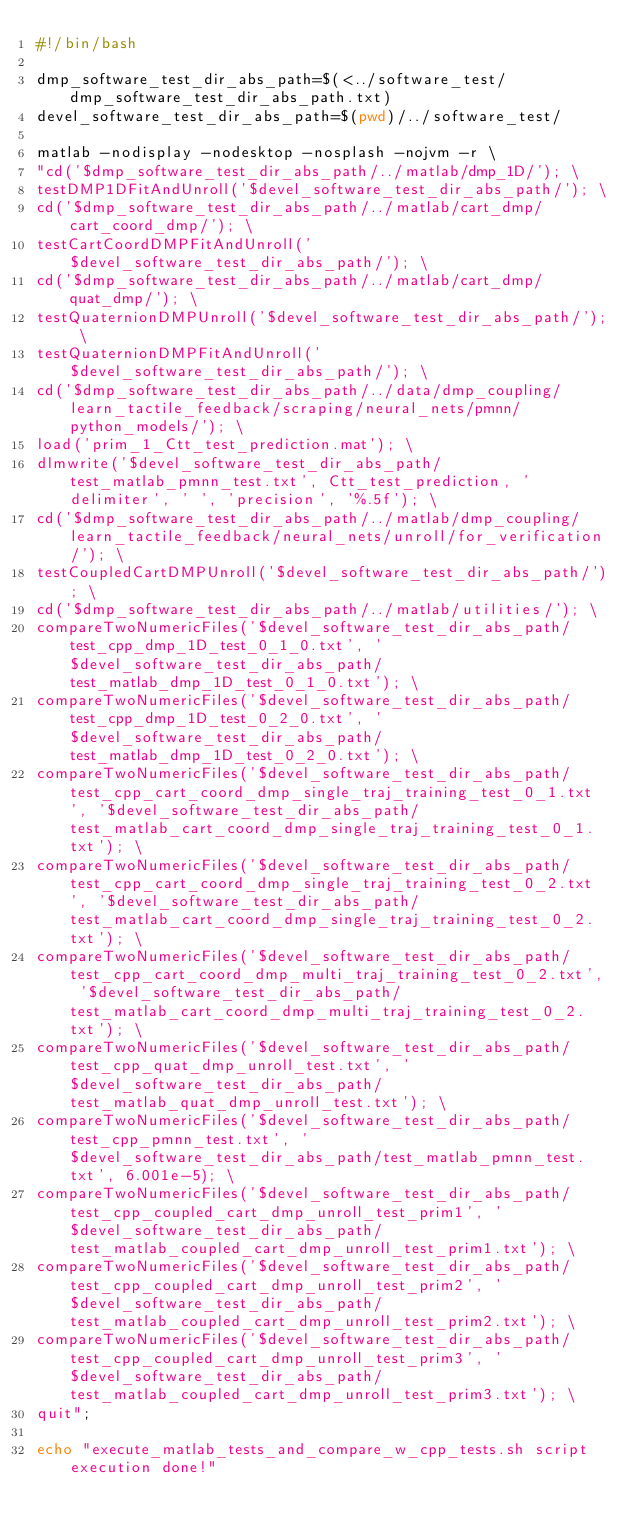Convert code to text. <code><loc_0><loc_0><loc_500><loc_500><_Bash_>#!/bin/bash

dmp_software_test_dir_abs_path=$(<../software_test/dmp_software_test_dir_abs_path.txt)
devel_software_test_dir_abs_path=$(pwd)/../software_test/

matlab -nodisplay -nodesktop -nosplash -nojvm -r \
"cd('$dmp_software_test_dir_abs_path/../matlab/dmp_1D/'); \
testDMP1DFitAndUnroll('$devel_software_test_dir_abs_path/'); \
cd('$dmp_software_test_dir_abs_path/../matlab/cart_dmp/cart_coord_dmp/'); \
testCartCoordDMPFitAndUnroll('$devel_software_test_dir_abs_path/'); \
cd('$dmp_software_test_dir_abs_path/../matlab/cart_dmp/quat_dmp/'); \
testQuaternionDMPUnroll('$devel_software_test_dir_abs_path/'); \
testQuaternionDMPFitAndUnroll('$devel_software_test_dir_abs_path/'); \
cd('$dmp_software_test_dir_abs_path/../data/dmp_coupling/learn_tactile_feedback/scraping/neural_nets/pmnn/python_models/'); \
load('prim_1_Ctt_test_prediction.mat'); \
dlmwrite('$devel_software_test_dir_abs_path/test_matlab_pmnn_test.txt', Ctt_test_prediction, 'delimiter', ' ', 'precision', '%.5f'); \
cd('$dmp_software_test_dir_abs_path/../matlab/dmp_coupling/learn_tactile_feedback/neural_nets/unroll/for_verification/'); \
testCoupledCartDMPUnroll('$devel_software_test_dir_abs_path/'); \
cd('$dmp_software_test_dir_abs_path/../matlab/utilities/'); \
compareTwoNumericFiles('$devel_software_test_dir_abs_path/test_cpp_dmp_1D_test_0_1_0.txt', '$devel_software_test_dir_abs_path/test_matlab_dmp_1D_test_0_1_0.txt'); \
compareTwoNumericFiles('$devel_software_test_dir_abs_path/test_cpp_dmp_1D_test_0_2_0.txt', '$devel_software_test_dir_abs_path/test_matlab_dmp_1D_test_0_2_0.txt'); \
compareTwoNumericFiles('$devel_software_test_dir_abs_path/test_cpp_cart_coord_dmp_single_traj_training_test_0_1.txt', '$devel_software_test_dir_abs_path/test_matlab_cart_coord_dmp_single_traj_training_test_0_1.txt'); \
compareTwoNumericFiles('$devel_software_test_dir_abs_path/test_cpp_cart_coord_dmp_single_traj_training_test_0_2.txt', '$devel_software_test_dir_abs_path/test_matlab_cart_coord_dmp_single_traj_training_test_0_2.txt'); \
compareTwoNumericFiles('$devel_software_test_dir_abs_path/test_cpp_cart_coord_dmp_multi_traj_training_test_0_2.txt', '$devel_software_test_dir_abs_path/test_matlab_cart_coord_dmp_multi_traj_training_test_0_2.txt'); \
compareTwoNumericFiles('$devel_software_test_dir_abs_path/test_cpp_quat_dmp_unroll_test.txt', '$devel_software_test_dir_abs_path/test_matlab_quat_dmp_unroll_test.txt'); \
compareTwoNumericFiles('$devel_software_test_dir_abs_path/test_cpp_pmnn_test.txt', '$devel_software_test_dir_abs_path/test_matlab_pmnn_test.txt', 6.001e-5); \
compareTwoNumericFiles('$devel_software_test_dir_abs_path/test_cpp_coupled_cart_dmp_unroll_test_prim1', '$devel_software_test_dir_abs_path/test_matlab_coupled_cart_dmp_unroll_test_prim1.txt'); \
compareTwoNumericFiles('$devel_software_test_dir_abs_path/test_cpp_coupled_cart_dmp_unroll_test_prim2', '$devel_software_test_dir_abs_path/test_matlab_coupled_cart_dmp_unroll_test_prim2.txt'); \
compareTwoNumericFiles('$devel_software_test_dir_abs_path/test_cpp_coupled_cart_dmp_unroll_test_prim3', '$devel_software_test_dir_abs_path/test_matlab_coupled_cart_dmp_unroll_test_prim3.txt'); \
quit";

echo "execute_matlab_tests_and_compare_w_cpp_tests.sh script execution done!"
</code> 